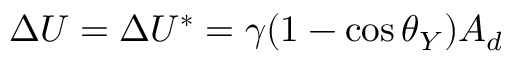<formula> <loc_0><loc_0><loc_500><loc_500>\Delta U = \Delta U ^ { * } = \gamma ( 1 - \cos \theta _ { Y } ) A _ { d }</formula> 